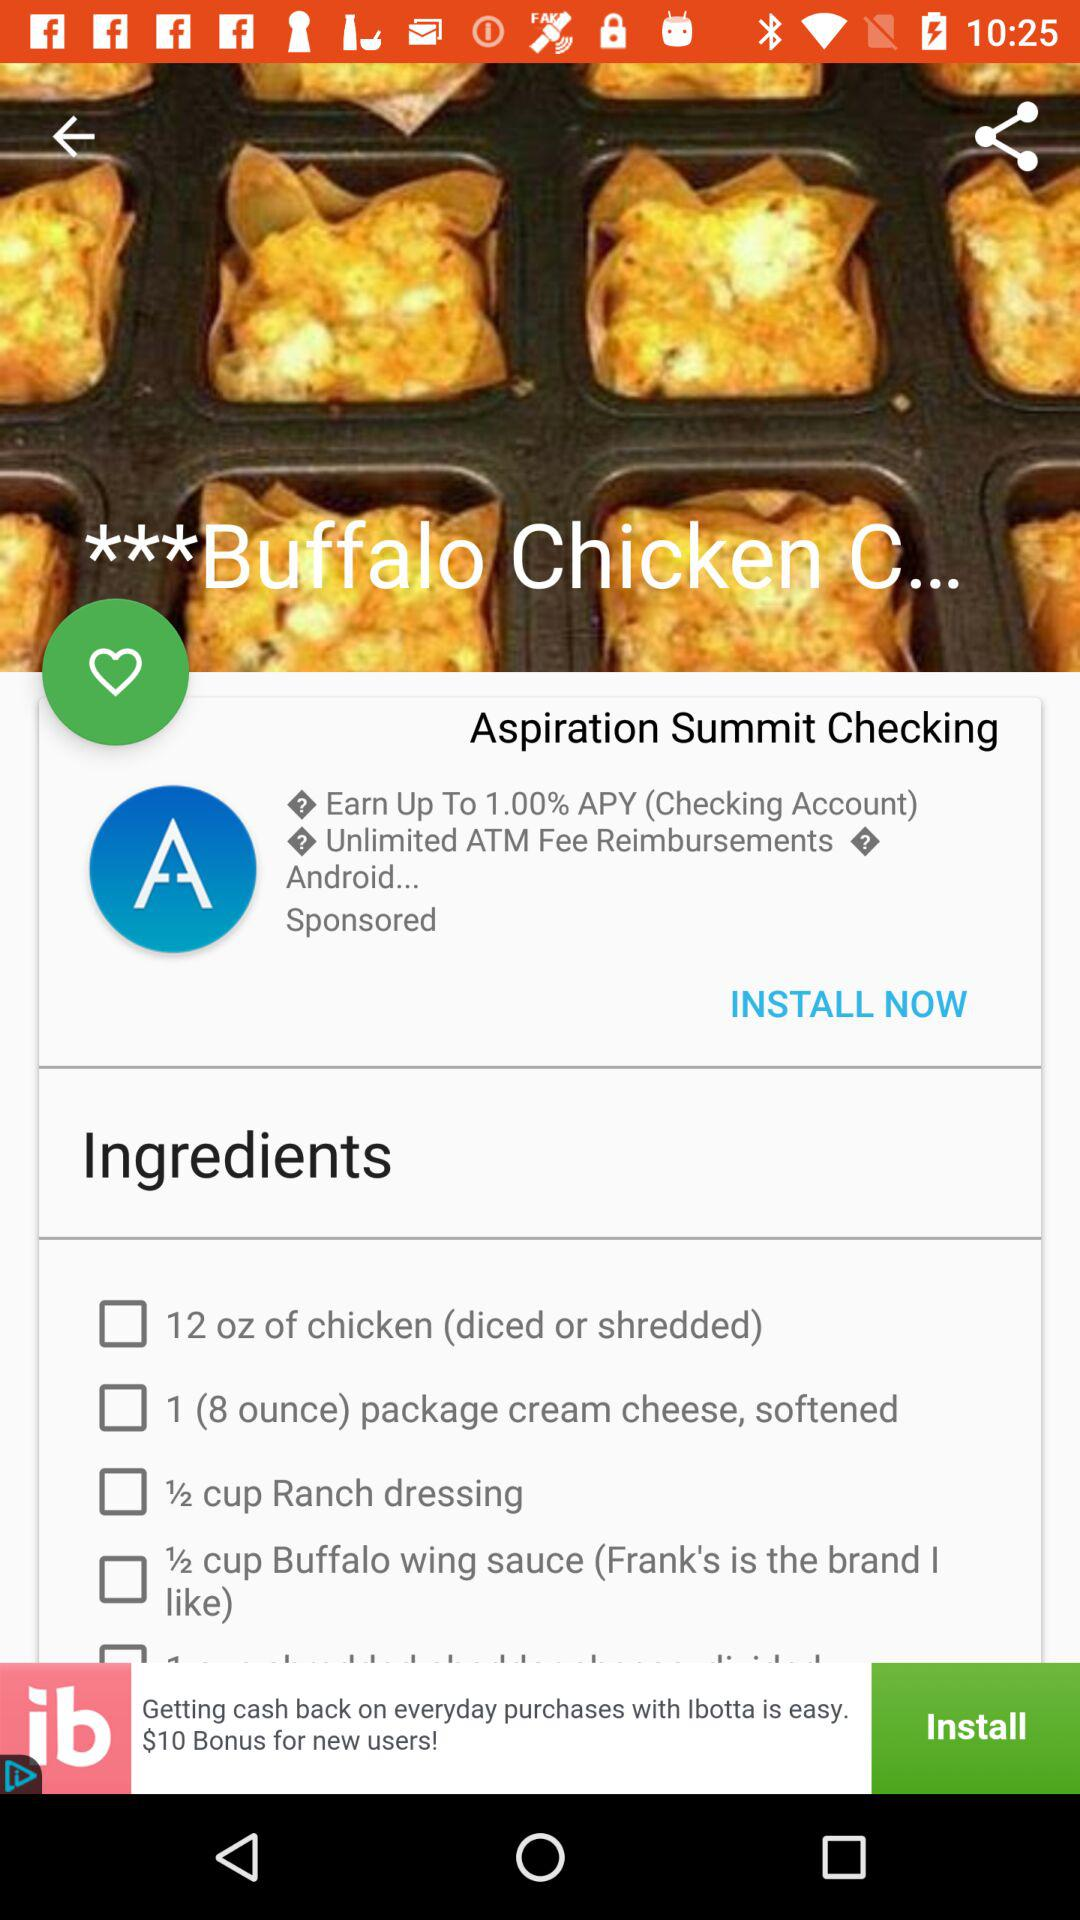How many "oz" of chicken are required to make "Buffalo Chicken"? To make "Buffalo Chicken", 12 "oz" of chicken are required. 